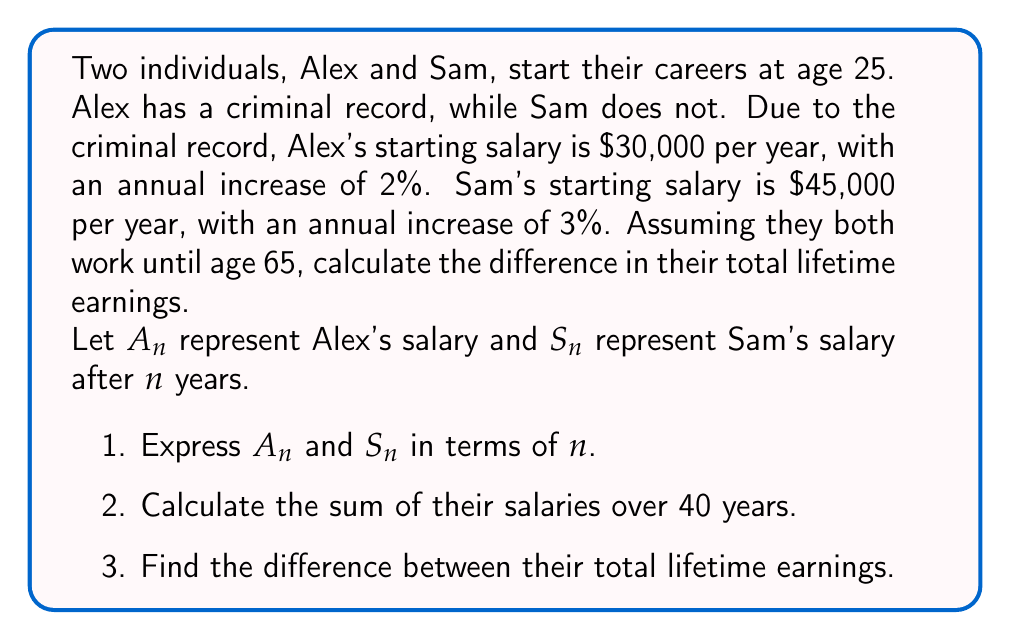Could you help me with this problem? Let's approach this problem step-by-step:

1) Expressing $A_n$ and $S_n$ in terms of $n$:

   For Alex: $A_n = 30000 \cdot (1.02)^n$
   For Sam: $S_n = 45000 \cdot (1.03)^n$

2) Calculating the sum of their salaries over 40 years:

   We need to use the formula for the sum of a geometric series:
   $$S = a \cdot \frac{1-r^n}{1-r}$$
   where $a$ is the first term, $r$ is the common ratio, and $n$ is the number of terms.

   For Alex:
   $a = 30000$, $r = 1.02$, $n = 40$
   $$A_{total} = 30000 \cdot \frac{1-(1.02)^{40}}{1-1.02} = 30000 \cdot \frac{1-2.208}{-0.02} = 1,803,000$$

   For Sam:
   $a = 45000$, $r = 1.03$, $n = 40$
   $$S_{total} = 45000 \cdot \frac{1-(1.03)^{40}}{1-1.03} = 45000 \cdot \frac{1-3.262}{-0.03} = 3,383,250$$

3) Finding the difference between their total lifetime earnings:

   Difference = $S_{total} - A_{total} = 3,383,250 - 1,803,000 = 1,580,250$
Answer: The difference in total lifetime earnings between Sam and Alex is $1,580,250. This demonstrates the significant long-term financial impact of a criminal record on earning potential. 